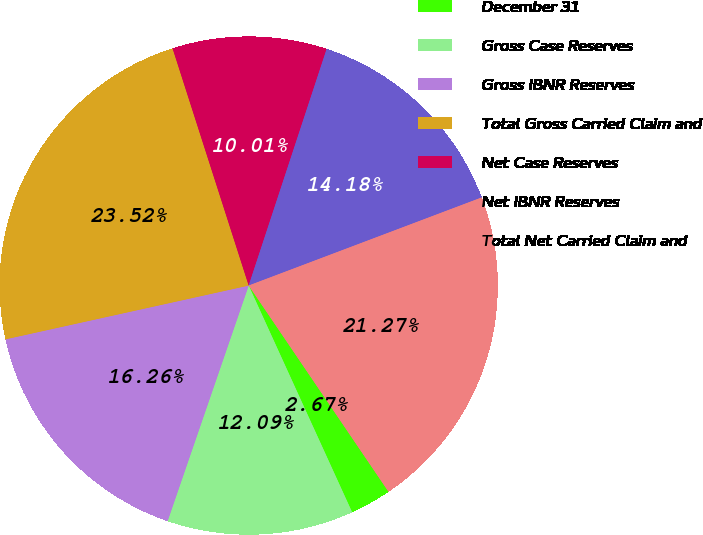Convert chart. <chart><loc_0><loc_0><loc_500><loc_500><pie_chart><fcel>December 31<fcel>Gross Case Reserves<fcel>Gross IBNR Reserves<fcel>Total Gross Carried Claim and<fcel>Net Case Reserves<fcel>Net IBNR Reserves<fcel>Total Net Carried Claim and<nl><fcel>2.67%<fcel>12.09%<fcel>16.26%<fcel>23.52%<fcel>10.01%<fcel>14.18%<fcel>21.27%<nl></chart> 